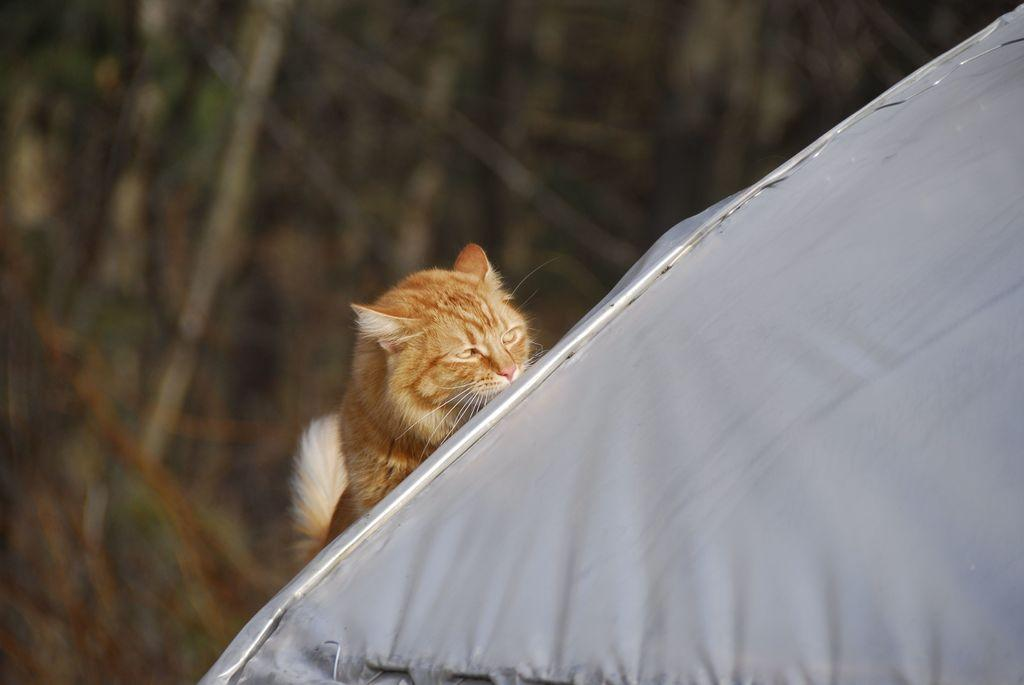What is the main subject in the center of the image? There is a cat in the center of the image. What structure can be seen on the right side of the image? There is a tent on the right side of the image. What type of natural environment is visible in the background of the image? There are trees in the background of the image. What is the cat's annual income in the image? The image does not provide information about the cat's income, as it is not relevant to the visual content. 